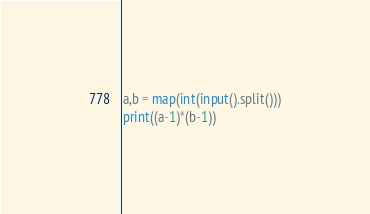Convert code to text. <code><loc_0><loc_0><loc_500><loc_500><_Python_>a,b = map(int(input().split()))
print((a-1)*(b-1))
</code> 